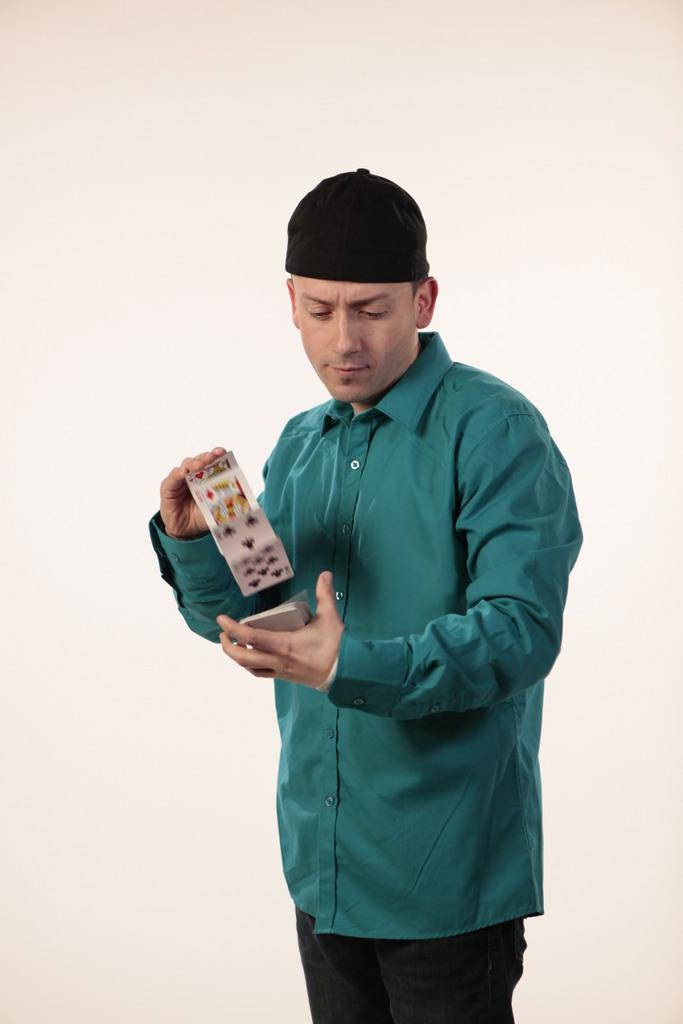What is the main subject of the image? The main subject of the image is a man. What is the man doing in the image? The man is playing with cards in the image. What type of clothing is the man wearing on his upper body? The man is wearing a shirt in the image. What type of clothing is the man wearing on his lower body? The man is wearing trousers in the image. What type of headwear is the man wearing? The man is wearing a black cap in the image. What type of needle is the man using to sew his brain in the image? There is no needle or mention of sewing the man's brain in the image. 